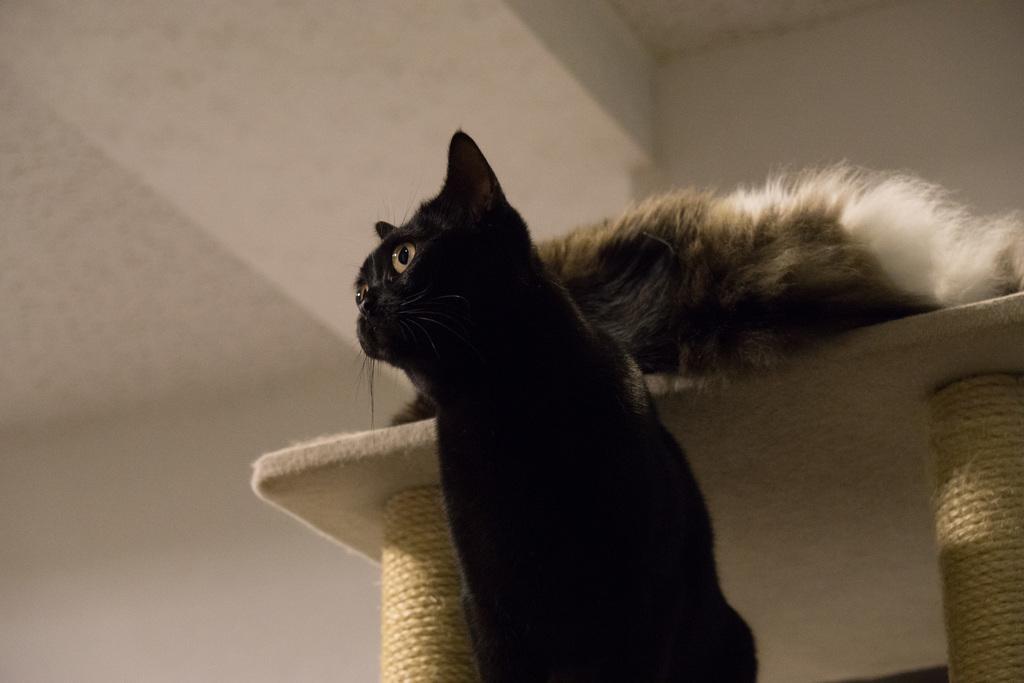Describe this image in one or two sentences. As we can see in the image there is white color wall, table and two cats. The cat in the front is in black color. 